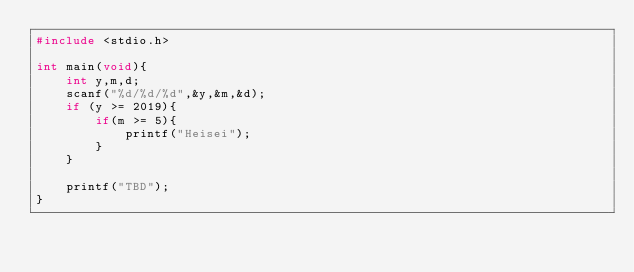Convert code to text. <code><loc_0><loc_0><loc_500><loc_500><_C_>#include <stdio.h>

int main(void){
    int y,m,d;
    scanf("%d/%d/%d",&y,&m,&d);
    if (y >= 2019){
        if(m >= 5){
            printf("Heisei");
        }
    }

    printf("TBD");
}</code> 